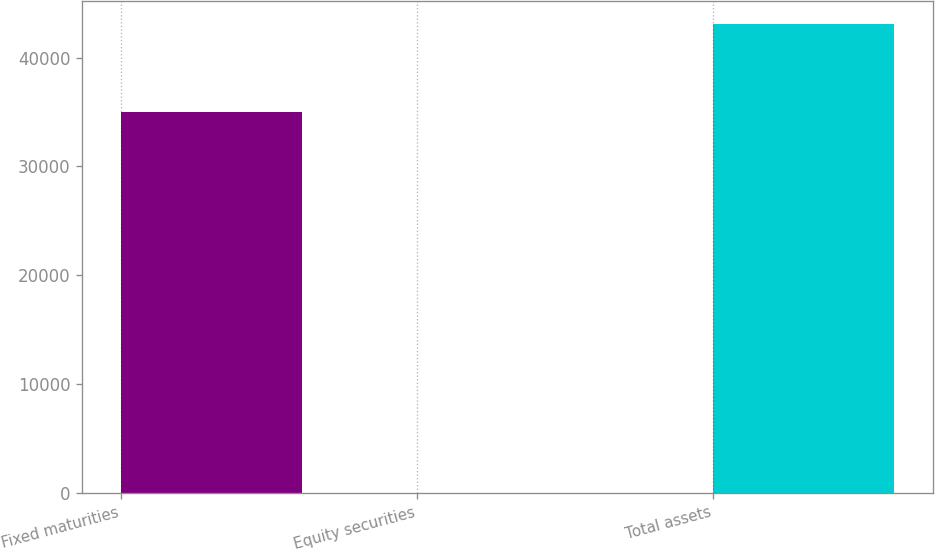Convert chart to OTSL. <chart><loc_0><loc_0><loc_500><loc_500><bar_chart><fcel>Fixed maturities<fcel>Equity securities<fcel>Total assets<nl><fcel>35012<fcel>27<fcel>43086<nl></chart> 